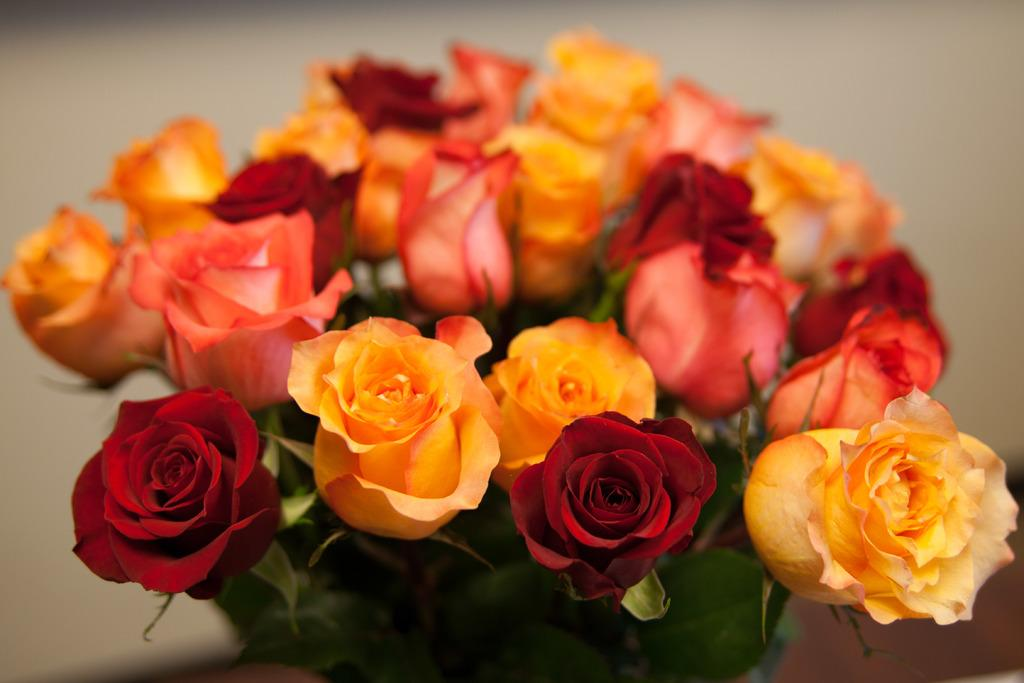What type of flowers are in the image? There is a bunch of rose flowers in the image. Can you describe the background of the image? The background of the image is blurred. How many spoons are visible in the image? There are no spoons present in the image; it only features a bunch of rose flowers with a blurred background. 